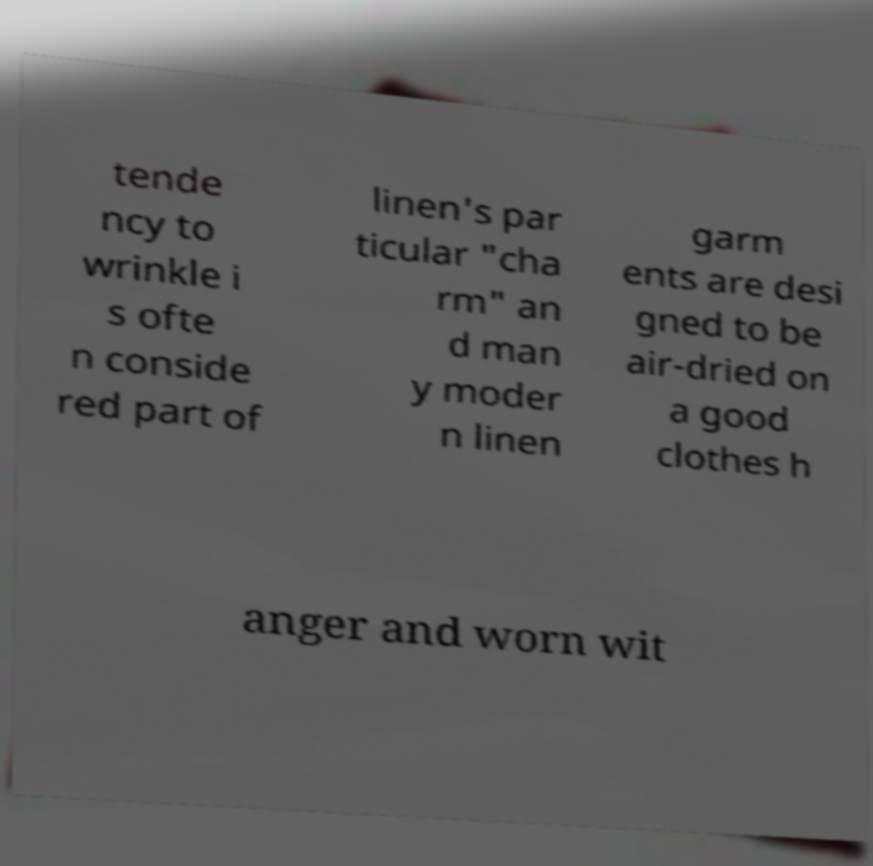Can you read and provide the text displayed in the image?This photo seems to have some interesting text. Can you extract and type it out for me? tende ncy to wrinkle i s ofte n conside red part of linen's par ticular "cha rm" an d man y moder n linen garm ents are desi gned to be air-dried on a good clothes h anger and worn wit 